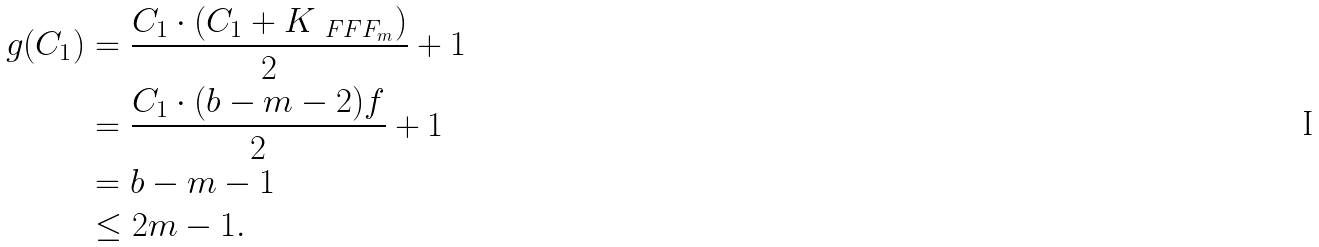Convert formula to latex. <formula><loc_0><loc_0><loc_500><loc_500>g ( C _ { 1 } ) & = \frac { C _ { 1 } \cdot ( C _ { 1 } + K _ { \ F F F _ { m } } ) } { 2 } + 1 \\ & = \frac { C _ { 1 } \cdot ( b - m - 2 ) f } { 2 } + 1 \\ & = b - m - 1 \\ & \leq 2 m - 1 .</formula> 